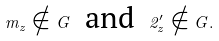<formula> <loc_0><loc_0><loc_500><loc_500>m _ { z } \notin G \text { \ and \ } 2 _ { z } ^ { \prime } \notin G .</formula> 